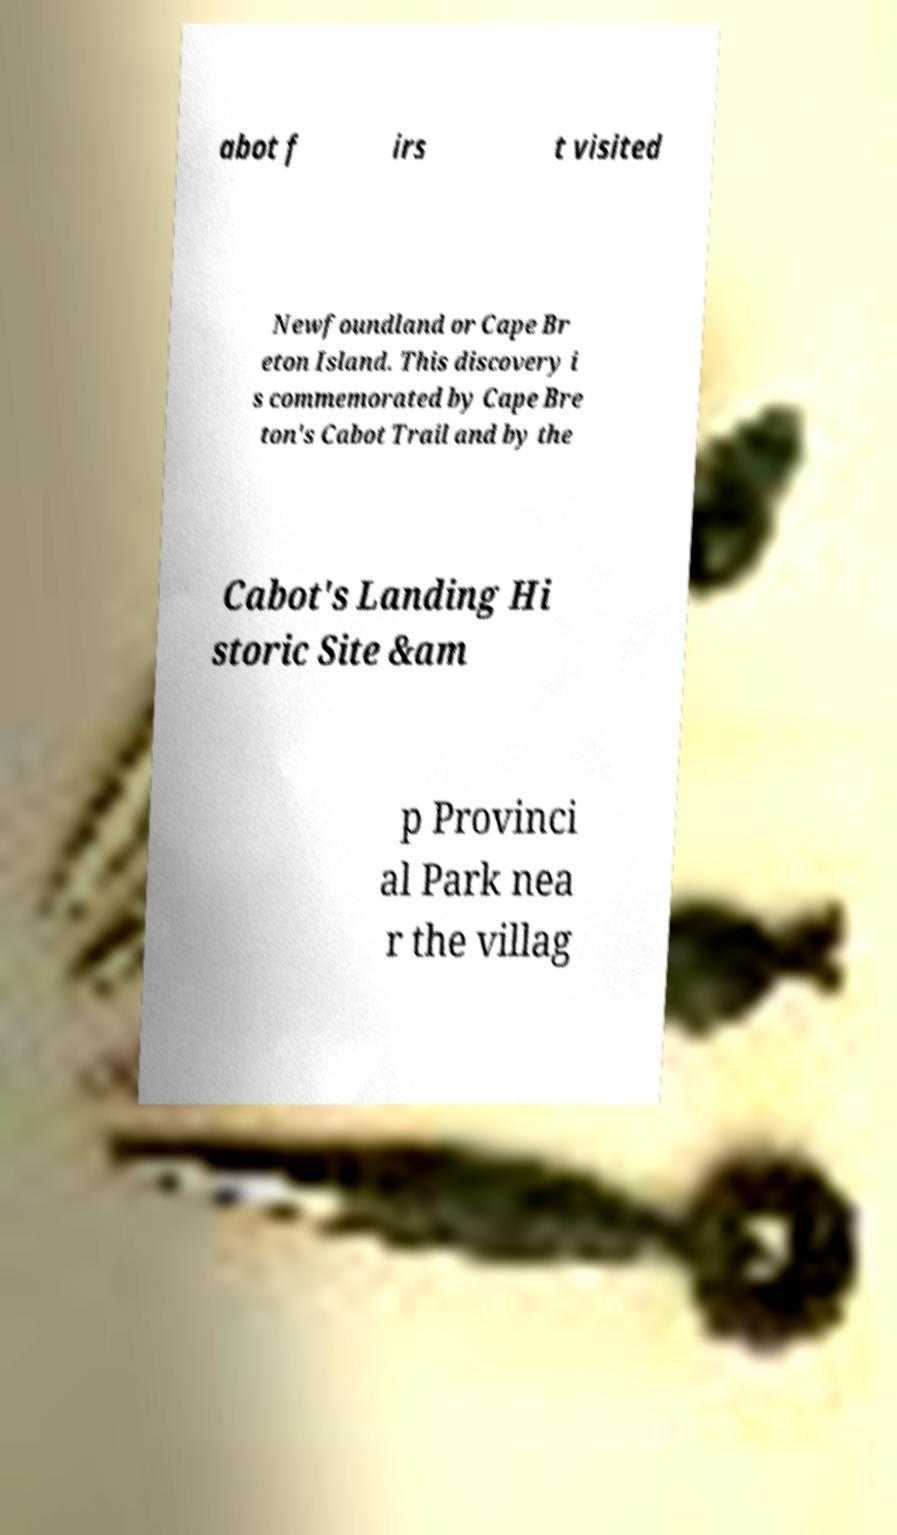There's text embedded in this image that I need extracted. Can you transcribe it verbatim? abot f irs t visited Newfoundland or Cape Br eton Island. This discovery i s commemorated by Cape Bre ton's Cabot Trail and by the Cabot's Landing Hi storic Site &am p Provinci al Park nea r the villag 